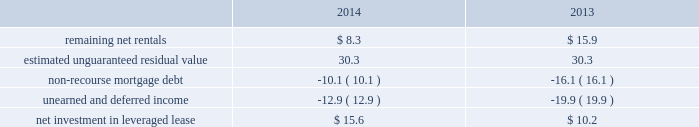Kimco realty corporation and subsidiaries notes to consolidated financial statements , continued during 2012 , the albertsons joint venture distributed $ 50.3 million of which the company received $ 6.9 million , which was recognized as income from cash received in excess of the company 2019s investment , before income tax , and is included in equity in income from other real estate investments , net on the company 2019s consolidated statements of income .
In january 2015 , the company invested an additional $ 85.3 million of new equity in the company 2019s albertsons joint venture to facilitate the acquisition of safeway inc .
By the cerberus lead consortium .
As a result , kimco now holds a 9.8% ( 9.8 % ) ownership interest in the combined company which operates 2230 stores across 34 states .
Leveraged lease - during june 2002 , the company acquired a 90% ( 90 % ) equity participation interest in an existing leveraged lease of 30 properties .
The properties are leased under a long-term bond-type net lease whose primary term expires in 2016 , with the lessee having certain renewal option rights .
The company 2019s cash equity investment was $ 4.0 million .
This equity investment is reported as a net investment in leveraged lease in accordance with the fasb 2019s lease guidance .
As of december 31 , 2014 , 19 of these properties were sold , whereby the proceeds from the sales were used to pay down $ 32.3 million in mortgage debt and the remaining 11 properties remain encumbered by third-party non-recourse debt of $ 11.2 million that is scheduled to fully amortize during the primary term of the lease from a portion of the periodic net rents receivable under the net lease .
As an equity participant in the leveraged lease , the company has no recourse obligation for principal or interest payments on the debt , which is collateralized by a first mortgage lien on the properties and collateral assignment of the lease .
Accordingly , this obligation has been offset against the related net rental receivable under the lease .
At december 31 , 2014 and 2013 , the company 2019s net investment in the leveraged lease consisted of the following ( in millions ) : .
Variable interest entities : consolidated ground-up development projects included within the company 2019s ground-up development projects at december 31 , 2014 , is an entity that is a vie , for which the company is the primary beneficiary .
This entity was established to develop real estate property to hold as a long-term investment .
The company 2019s involvement with this entity is through its majority ownership and management of the property .
This entity was deemed a vie primarily based on the fact that the equity investment at risk is not sufficient to permit the entity to finance its activities without additional financial support .
The initial equity contributed to this entity was not sufficient to fully finance the real estate construction as development costs are funded by the partners throughout the construction period .
The company determined that it was the primary beneficiary of this vie as a result of its controlling financial interest .
At december 31 , 2014 , total assets of this ground-up development vie were $ 77.7 million and total liabilities were $ 0.1 million .
The classification of these assets is primarily within real estate under development in the company 2019s consolidated balance sheets and the classifications of liabilities are primarily within accounts payable and accrued expenses on the company 2019s consolidated balance sheets .
Substantially all of the projected development costs to be funded for this ground-up development vie , aggregating $ 32.8 million , will be funded with capital contributions from the company and by the outside partners , when contractually obligated .
The company has not provided financial support to this vie that it was not previously contractually required to provide. .
At december 31 , 2014 what was the amount of the equity in millions for the , ground-up development vie in millions .? 
Computations: (77.7 - 0.1)
Answer: 77.6. 